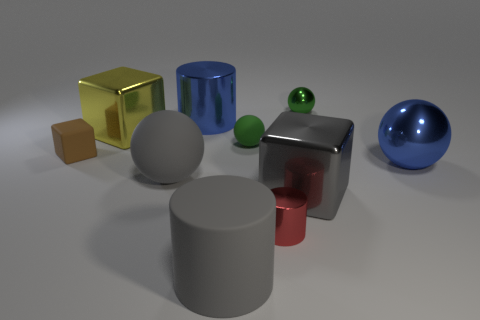Subtract all gray cylinders. How many green spheres are left? 2 Subtract all large cylinders. How many cylinders are left? 1 Subtract 1 balls. How many balls are left? 3 Subtract all blue spheres. How many spheres are left? 3 Subtract all purple spheres. Subtract all red blocks. How many spheres are left? 4 Subtract all cubes. How many objects are left? 7 Add 6 shiny cylinders. How many shiny cylinders exist? 8 Subtract 0 brown cylinders. How many objects are left? 10 Subtract all big blocks. Subtract all big spheres. How many objects are left? 6 Add 9 big gray balls. How many big gray balls are left? 10 